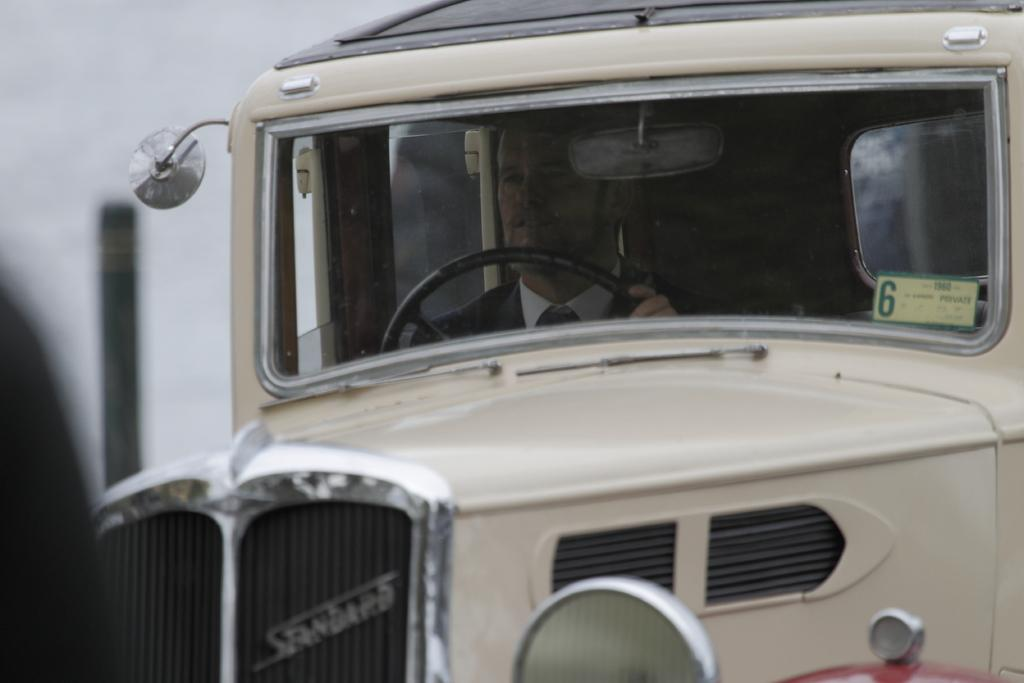What is the person in the image wearing? The person in the image is wearing a suit. What is the person doing in the image? The person is driving a vehicle. What color is the vehicle the person is driving? The vehicle is white in color. What can be seen in the background of the image? There is a pole in the background of the image. What is the color of the background in the image? The background is white in color. Can you see a pig tied to a chain in the image? There is no pig or chain present in the image. What type of boundary is visible in the image? There is no boundary visible in the image. 